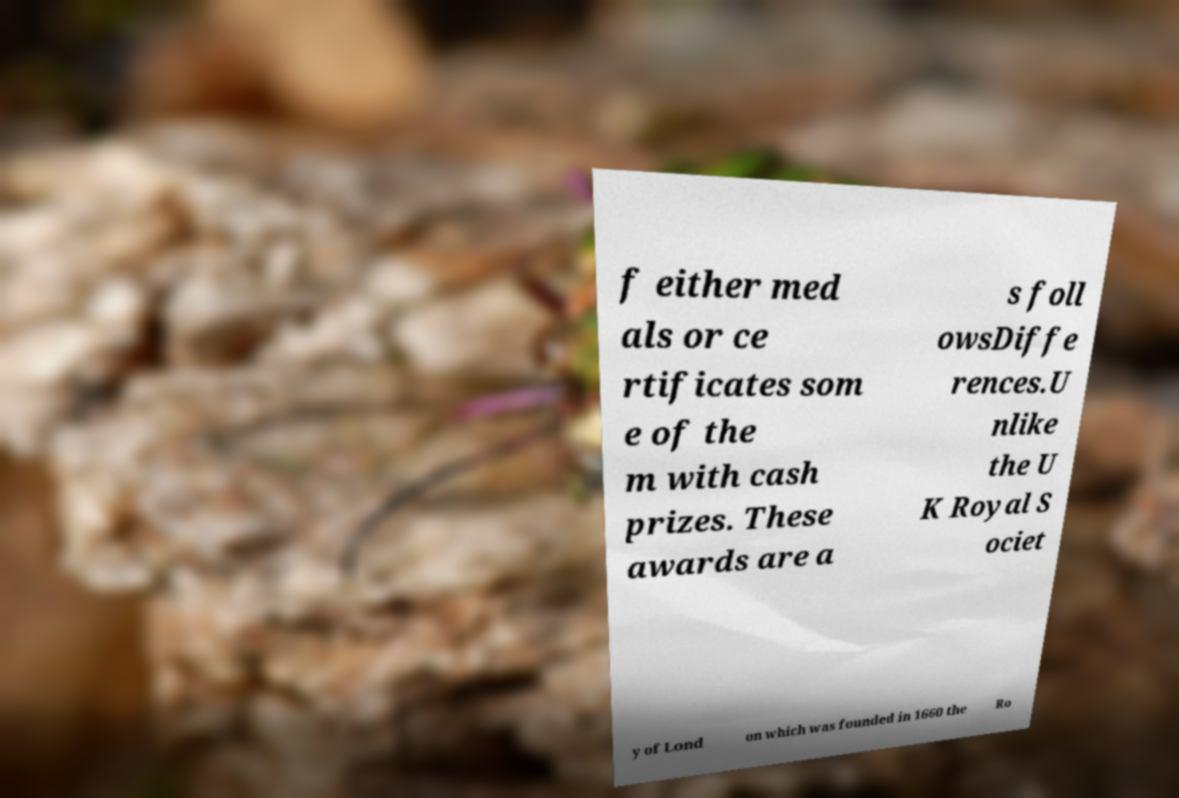What messages or text are displayed in this image? I need them in a readable, typed format. f either med als or ce rtificates som e of the m with cash prizes. These awards are a s foll owsDiffe rences.U nlike the U K Royal S ociet y of Lond on which was founded in 1660 the Ro 